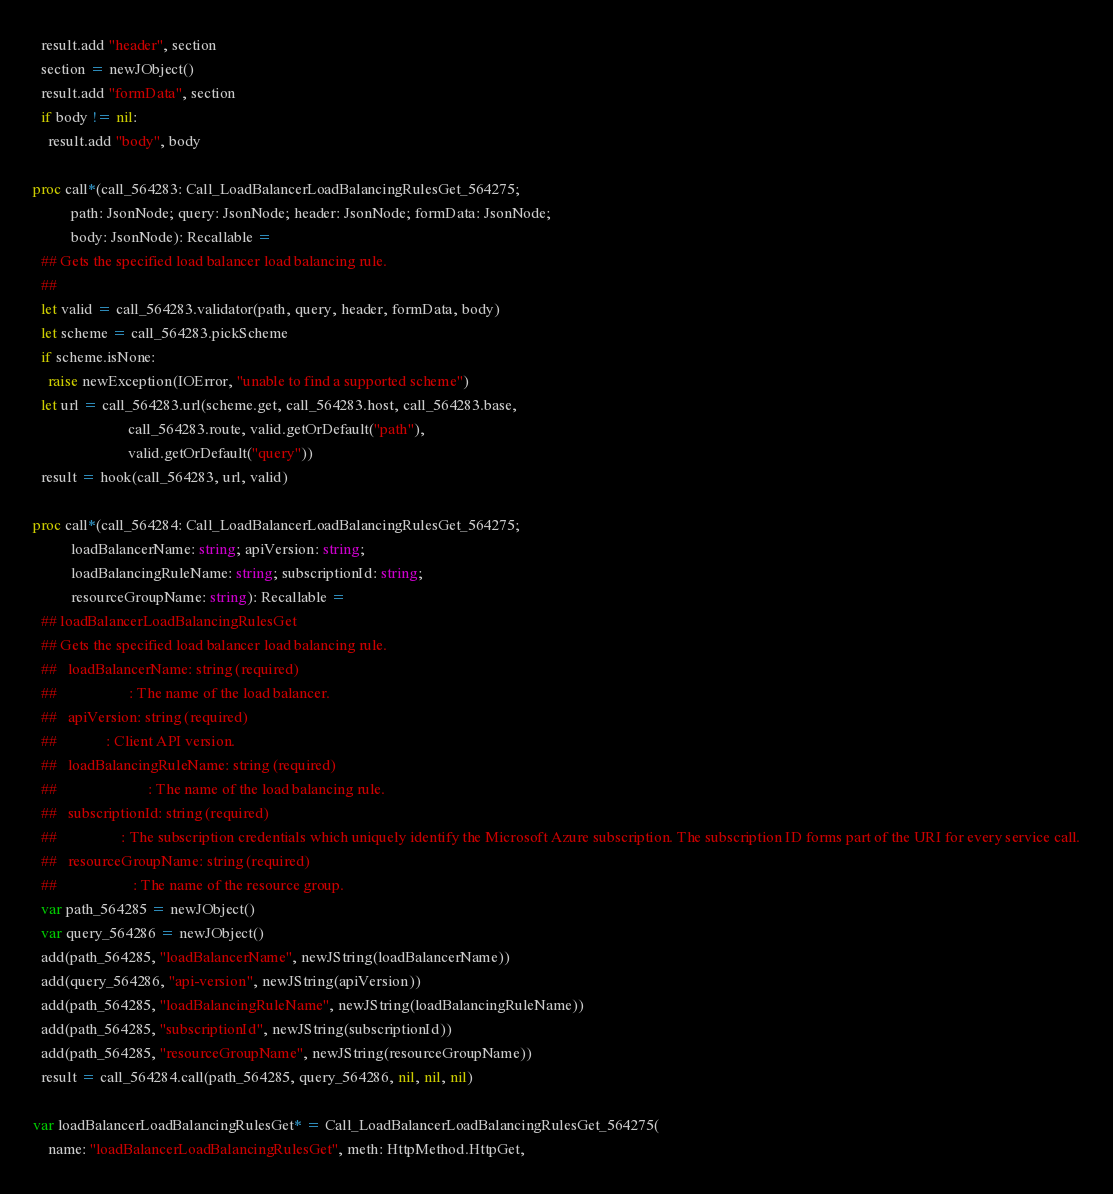Convert code to text. <code><loc_0><loc_0><loc_500><loc_500><_Nim_>  result.add "header", section
  section = newJObject()
  result.add "formData", section
  if body != nil:
    result.add "body", body

proc call*(call_564283: Call_LoadBalancerLoadBalancingRulesGet_564275;
          path: JsonNode; query: JsonNode; header: JsonNode; formData: JsonNode;
          body: JsonNode): Recallable =
  ## Gets the specified load balancer load balancing rule.
  ## 
  let valid = call_564283.validator(path, query, header, formData, body)
  let scheme = call_564283.pickScheme
  if scheme.isNone:
    raise newException(IOError, "unable to find a supported scheme")
  let url = call_564283.url(scheme.get, call_564283.host, call_564283.base,
                         call_564283.route, valid.getOrDefault("path"),
                         valid.getOrDefault("query"))
  result = hook(call_564283, url, valid)

proc call*(call_564284: Call_LoadBalancerLoadBalancingRulesGet_564275;
          loadBalancerName: string; apiVersion: string;
          loadBalancingRuleName: string; subscriptionId: string;
          resourceGroupName: string): Recallable =
  ## loadBalancerLoadBalancingRulesGet
  ## Gets the specified load balancer load balancing rule.
  ##   loadBalancerName: string (required)
  ##                   : The name of the load balancer.
  ##   apiVersion: string (required)
  ##             : Client API version.
  ##   loadBalancingRuleName: string (required)
  ##                        : The name of the load balancing rule.
  ##   subscriptionId: string (required)
  ##                 : The subscription credentials which uniquely identify the Microsoft Azure subscription. The subscription ID forms part of the URI for every service call.
  ##   resourceGroupName: string (required)
  ##                    : The name of the resource group.
  var path_564285 = newJObject()
  var query_564286 = newJObject()
  add(path_564285, "loadBalancerName", newJString(loadBalancerName))
  add(query_564286, "api-version", newJString(apiVersion))
  add(path_564285, "loadBalancingRuleName", newJString(loadBalancingRuleName))
  add(path_564285, "subscriptionId", newJString(subscriptionId))
  add(path_564285, "resourceGroupName", newJString(resourceGroupName))
  result = call_564284.call(path_564285, query_564286, nil, nil, nil)

var loadBalancerLoadBalancingRulesGet* = Call_LoadBalancerLoadBalancingRulesGet_564275(
    name: "loadBalancerLoadBalancingRulesGet", meth: HttpMethod.HttpGet,</code> 